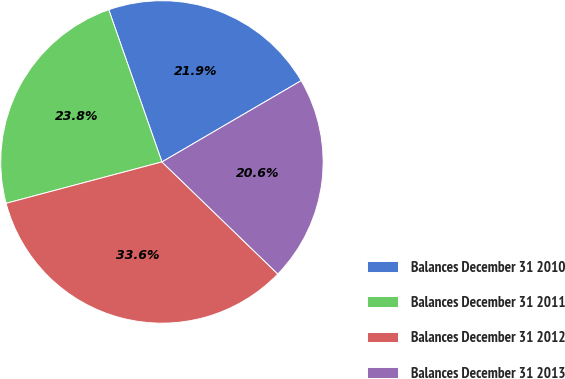Convert chart to OTSL. <chart><loc_0><loc_0><loc_500><loc_500><pie_chart><fcel>Balances December 31 2010<fcel>Balances December 31 2011<fcel>Balances December 31 2012<fcel>Balances December 31 2013<nl><fcel>21.94%<fcel>23.78%<fcel>33.63%<fcel>20.64%<nl></chart> 